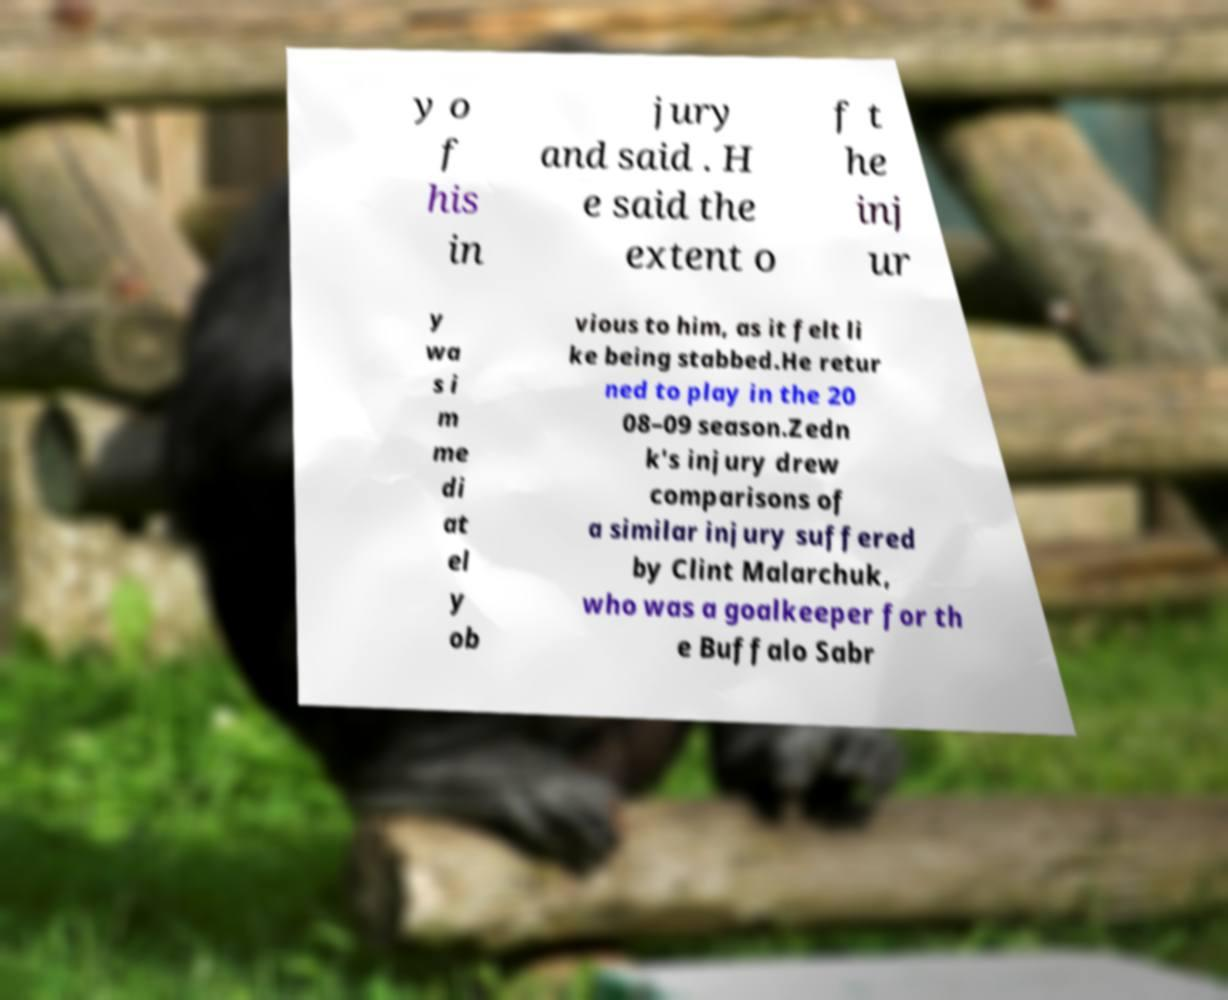Can you accurately transcribe the text from the provided image for me? y o f his in jury and said . H e said the extent o f t he inj ur y wa s i m me di at el y ob vious to him, as it felt li ke being stabbed.He retur ned to play in the 20 08–09 season.Zedn k's injury drew comparisons of a similar injury suffered by Clint Malarchuk, who was a goalkeeper for th e Buffalo Sabr 